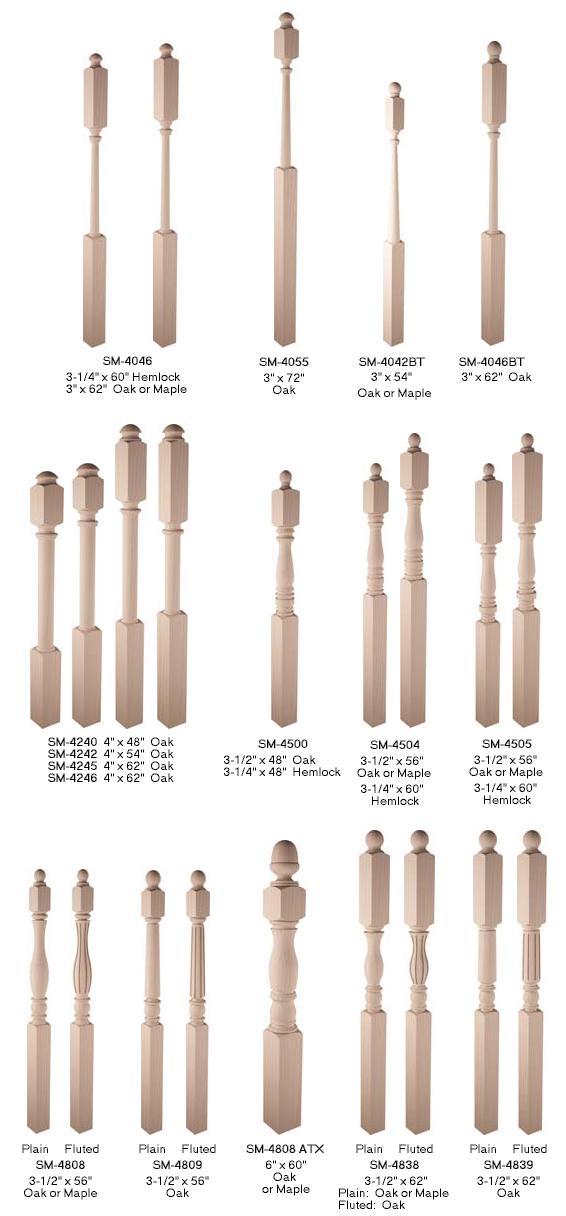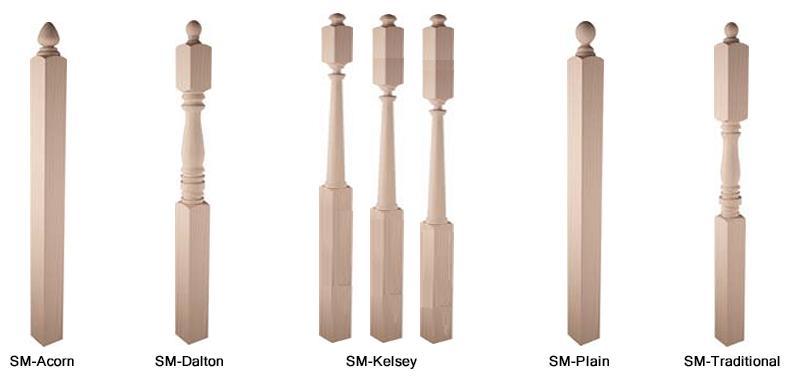The first image is the image on the left, the second image is the image on the right. Given the left and right images, does the statement "Each image contains at least one row of beige posts displayed vertically with space between each one." hold true? Answer yes or no. Yes. The first image is the image on the left, the second image is the image on the right. Given the left and right images, does the statement "In at least one image one of the row have seven  wooden rails." hold true? Answer yes or no. Yes. 